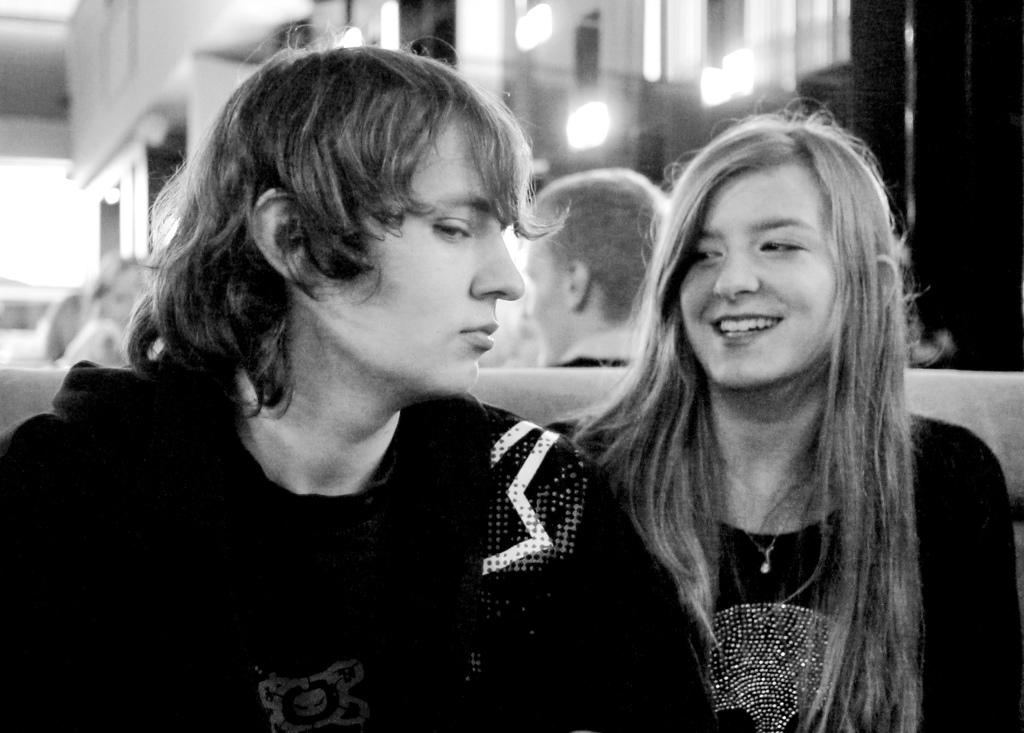What is the color scheme of the image? The image is black and white. What are the people in the image doing? The people in the image are sitting. Can you describe the background of the image? The background behind the people is blurred. How many kittens are playing in the sand in the image? There are no kittens or sand present in the image. 